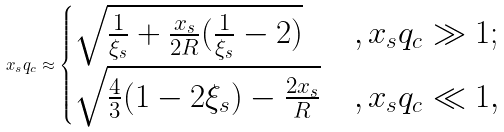<formula> <loc_0><loc_0><loc_500><loc_500>x _ { s } q _ { c } \approx \begin{cases} \sqrt { \frac { 1 } { \xi _ { s } } + \frac { x _ { s } } { 2 R } ( \frac { 1 } { \xi _ { s } } - 2 ) } & , x _ { s } q _ { c } \gg 1 ; \\ \sqrt { \frac { 4 } { 3 } ( 1 - 2 \xi _ { s } ) - \frac { 2 x _ { s } } { R } } & , x _ { s } q _ { c } \ll 1 , \end{cases}</formula> 